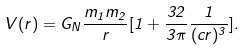Convert formula to latex. <formula><loc_0><loc_0><loc_500><loc_500>V ( r ) = G _ { N } \frac { m _ { 1 } m _ { 2 } } { r } [ 1 + \frac { 3 2 } { 3 \pi } \frac { 1 } { ( c r ) ^ { 3 } } ] .</formula> 